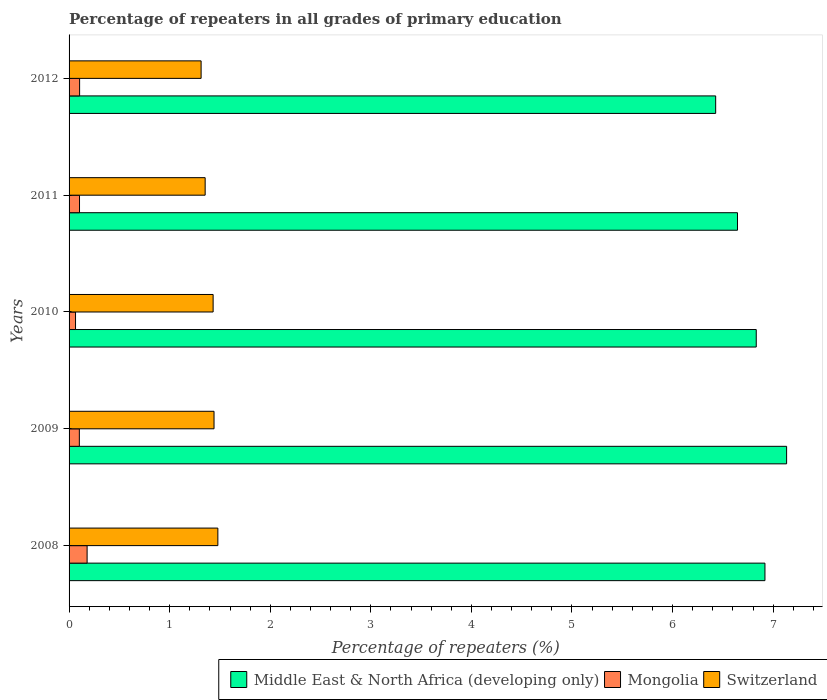How many different coloured bars are there?
Give a very brief answer. 3. How many bars are there on the 5th tick from the top?
Provide a short and direct response. 3. How many bars are there on the 2nd tick from the bottom?
Offer a terse response. 3. What is the percentage of repeaters in Middle East & North Africa (developing only) in 2008?
Offer a very short reply. 6.92. Across all years, what is the maximum percentage of repeaters in Mongolia?
Your answer should be very brief. 0.18. Across all years, what is the minimum percentage of repeaters in Switzerland?
Make the answer very short. 1.31. What is the total percentage of repeaters in Middle East & North Africa (developing only) in the graph?
Your response must be concise. 33.96. What is the difference between the percentage of repeaters in Mongolia in 2011 and that in 2012?
Offer a terse response. -0. What is the difference between the percentage of repeaters in Mongolia in 2008 and the percentage of repeaters in Middle East & North Africa (developing only) in 2012?
Provide a short and direct response. -6.25. What is the average percentage of repeaters in Middle East & North Africa (developing only) per year?
Provide a short and direct response. 6.79. In the year 2012, what is the difference between the percentage of repeaters in Middle East & North Africa (developing only) and percentage of repeaters in Switzerland?
Ensure brevity in your answer.  5.12. In how many years, is the percentage of repeaters in Switzerland greater than 3.2 %?
Make the answer very short. 0. What is the ratio of the percentage of repeaters in Switzerland in 2009 to that in 2010?
Your answer should be very brief. 1.01. What is the difference between the highest and the second highest percentage of repeaters in Middle East & North Africa (developing only)?
Your response must be concise. 0.22. What is the difference between the highest and the lowest percentage of repeaters in Middle East & North Africa (developing only)?
Ensure brevity in your answer.  0.71. What does the 3rd bar from the top in 2009 represents?
Your answer should be very brief. Middle East & North Africa (developing only). What does the 3rd bar from the bottom in 2009 represents?
Your answer should be very brief. Switzerland. What is the difference between two consecutive major ticks on the X-axis?
Make the answer very short. 1. Are the values on the major ticks of X-axis written in scientific E-notation?
Your answer should be compact. No. How are the legend labels stacked?
Provide a short and direct response. Horizontal. What is the title of the graph?
Keep it short and to the point. Percentage of repeaters in all grades of primary education. What is the label or title of the X-axis?
Your response must be concise. Percentage of repeaters (%). What is the Percentage of repeaters (%) of Middle East & North Africa (developing only) in 2008?
Provide a succinct answer. 6.92. What is the Percentage of repeaters (%) of Mongolia in 2008?
Provide a short and direct response. 0.18. What is the Percentage of repeaters (%) of Switzerland in 2008?
Keep it short and to the point. 1.48. What is the Percentage of repeaters (%) of Middle East & North Africa (developing only) in 2009?
Offer a terse response. 7.13. What is the Percentage of repeaters (%) in Mongolia in 2009?
Your response must be concise. 0.1. What is the Percentage of repeaters (%) of Switzerland in 2009?
Provide a succinct answer. 1.44. What is the Percentage of repeaters (%) in Middle East & North Africa (developing only) in 2010?
Offer a very short reply. 6.83. What is the Percentage of repeaters (%) in Mongolia in 2010?
Provide a short and direct response. 0.06. What is the Percentage of repeaters (%) in Switzerland in 2010?
Your response must be concise. 1.43. What is the Percentage of repeaters (%) in Middle East & North Africa (developing only) in 2011?
Provide a short and direct response. 6.65. What is the Percentage of repeaters (%) of Mongolia in 2011?
Your answer should be very brief. 0.1. What is the Percentage of repeaters (%) in Switzerland in 2011?
Offer a terse response. 1.35. What is the Percentage of repeaters (%) in Middle East & North Africa (developing only) in 2012?
Your answer should be compact. 6.43. What is the Percentage of repeaters (%) of Mongolia in 2012?
Provide a short and direct response. 0.1. What is the Percentage of repeaters (%) in Switzerland in 2012?
Offer a very short reply. 1.31. Across all years, what is the maximum Percentage of repeaters (%) of Middle East & North Africa (developing only)?
Your response must be concise. 7.13. Across all years, what is the maximum Percentage of repeaters (%) in Mongolia?
Provide a succinct answer. 0.18. Across all years, what is the maximum Percentage of repeaters (%) in Switzerland?
Your response must be concise. 1.48. Across all years, what is the minimum Percentage of repeaters (%) in Middle East & North Africa (developing only)?
Your answer should be very brief. 6.43. Across all years, what is the minimum Percentage of repeaters (%) in Mongolia?
Provide a succinct answer. 0.06. Across all years, what is the minimum Percentage of repeaters (%) in Switzerland?
Offer a very short reply. 1.31. What is the total Percentage of repeaters (%) in Middle East & North Africa (developing only) in the graph?
Make the answer very short. 33.96. What is the total Percentage of repeaters (%) of Mongolia in the graph?
Keep it short and to the point. 0.55. What is the total Percentage of repeaters (%) of Switzerland in the graph?
Your answer should be compact. 7.02. What is the difference between the Percentage of repeaters (%) of Middle East & North Africa (developing only) in 2008 and that in 2009?
Offer a very short reply. -0.22. What is the difference between the Percentage of repeaters (%) in Mongolia in 2008 and that in 2009?
Offer a terse response. 0.08. What is the difference between the Percentage of repeaters (%) of Switzerland in 2008 and that in 2009?
Ensure brevity in your answer.  0.04. What is the difference between the Percentage of repeaters (%) in Middle East & North Africa (developing only) in 2008 and that in 2010?
Your answer should be very brief. 0.09. What is the difference between the Percentage of repeaters (%) in Mongolia in 2008 and that in 2010?
Ensure brevity in your answer.  0.12. What is the difference between the Percentage of repeaters (%) of Switzerland in 2008 and that in 2010?
Offer a terse response. 0.05. What is the difference between the Percentage of repeaters (%) in Middle East & North Africa (developing only) in 2008 and that in 2011?
Make the answer very short. 0.27. What is the difference between the Percentage of repeaters (%) in Mongolia in 2008 and that in 2011?
Make the answer very short. 0.08. What is the difference between the Percentage of repeaters (%) in Switzerland in 2008 and that in 2011?
Give a very brief answer. 0.13. What is the difference between the Percentage of repeaters (%) of Middle East & North Africa (developing only) in 2008 and that in 2012?
Give a very brief answer. 0.49. What is the difference between the Percentage of repeaters (%) of Mongolia in 2008 and that in 2012?
Keep it short and to the point. 0.07. What is the difference between the Percentage of repeaters (%) in Switzerland in 2008 and that in 2012?
Offer a terse response. 0.17. What is the difference between the Percentage of repeaters (%) in Middle East & North Africa (developing only) in 2009 and that in 2010?
Ensure brevity in your answer.  0.3. What is the difference between the Percentage of repeaters (%) in Mongolia in 2009 and that in 2010?
Your answer should be compact. 0.04. What is the difference between the Percentage of repeaters (%) in Switzerland in 2009 and that in 2010?
Your answer should be compact. 0.01. What is the difference between the Percentage of repeaters (%) of Middle East & North Africa (developing only) in 2009 and that in 2011?
Keep it short and to the point. 0.49. What is the difference between the Percentage of repeaters (%) in Mongolia in 2009 and that in 2011?
Provide a short and direct response. -0. What is the difference between the Percentage of repeaters (%) in Switzerland in 2009 and that in 2011?
Offer a very short reply. 0.09. What is the difference between the Percentage of repeaters (%) in Middle East & North Africa (developing only) in 2009 and that in 2012?
Ensure brevity in your answer.  0.71. What is the difference between the Percentage of repeaters (%) of Mongolia in 2009 and that in 2012?
Keep it short and to the point. -0. What is the difference between the Percentage of repeaters (%) of Switzerland in 2009 and that in 2012?
Ensure brevity in your answer.  0.13. What is the difference between the Percentage of repeaters (%) of Middle East & North Africa (developing only) in 2010 and that in 2011?
Offer a terse response. 0.19. What is the difference between the Percentage of repeaters (%) of Mongolia in 2010 and that in 2011?
Your answer should be compact. -0.04. What is the difference between the Percentage of repeaters (%) of Switzerland in 2010 and that in 2011?
Make the answer very short. 0.08. What is the difference between the Percentage of repeaters (%) in Middle East & North Africa (developing only) in 2010 and that in 2012?
Provide a short and direct response. 0.4. What is the difference between the Percentage of repeaters (%) in Mongolia in 2010 and that in 2012?
Your response must be concise. -0.04. What is the difference between the Percentage of repeaters (%) of Switzerland in 2010 and that in 2012?
Offer a terse response. 0.12. What is the difference between the Percentage of repeaters (%) of Middle East & North Africa (developing only) in 2011 and that in 2012?
Give a very brief answer. 0.22. What is the difference between the Percentage of repeaters (%) in Mongolia in 2011 and that in 2012?
Your response must be concise. -0. What is the difference between the Percentage of repeaters (%) in Switzerland in 2011 and that in 2012?
Provide a short and direct response. 0.04. What is the difference between the Percentage of repeaters (%) of Middle East & North Africa (developing only) in 2008 and the Percentage of repeaters (%) of Mongolia in 2009?
Ensure brevity in your answer.  6.82. What is the difference between the Percentage of repeaters (%) of Middle East & North Africa (developing only) in 2008 and the Percentage of repeaters (%) of Switzerland in 2009?
Ensure brevity in your answer.  5.48. What is the difference between the Percentage of repeaters (%) of Mongolia in 2008 and the Percentage of repeaters (%) of Switzerland in 2009?
Your answer should be compact. -1.26. What is the difference between the Percentage of repeaters (%) of Middle East & North Africa (developing only) in 2008 and the Percentage of repeaters (%) of Mongolia in 2010?
Your answer should be very brief. 6.85. What is the difference between the Percentage of repeaters (%) in Middle East & North Africa (developing only) in 2008 and the Percentage of repeaters (%) in Switzerland in 2010?
Keep it short and to the point. 5.49. What is the difference between the Percentage of repeaters (%) in Mongolia in 2008 and the Percentage of repeaters (%) in Switzerland in 2010?
Provide a succinct answer. -1.25. What is the difference between the Percentage of repeaters (%) of Middle East & North Africa (developing only) in 2008 and the Percentage of repeaters (%) of Mongolia in 2011?
Offer a terse response. 6.82. What is the difference between the Percentage of repeaters (%) of Middle East & North Africa (developing only) in 2008 and the Percentage of repeaters (%) of Switzerland in 2011?
Keep it short and to the point. 5.57. What is the difference between the Percentage of repeaters (%) of Mongolia in 2008 and the Percentage of repeaters (%) of Switzerland in 2011?
Offer a very short reply. -1.17. What is the difference between the Percentage of repeaters (%) in Middle East & North Africa (developing only) in 2008 and the Percentage of repeaters (%) in Mongolia in 2012?
Offer a terse response. 6.81. What is the difference between the Percentage of repeaters (%) in Middle East & North Africa (developing only) in 2008 and the Percentage of repeaters (%) in Switzerland in 2012?
Provide a succinct answer. 5.61. What is the difference between the Percentage of repeaters (%) in Mongolia in 2008 and the Percentage of repeaters (%) in Switzerland in 2012?
Provide a short and direct response. -1.13. What is the difference between the Percentage of repeaters (%) of Middle East & North Africa (developing only) in 2009 and the Percentage of repeaters (%) of Mongolia in 2010?
Keep it short and to the point. 7.07. What is the difference between the Percentage of repeaters (%) of Middle East & North Africa (developing only) in 2009 and the Percentage of repeaters (%) of Switzerland in 2010?
Offer a very short reply. 5.7. What is the difference between the Percentage of repeaters (%) in Mongolia in 2009 and the Percentage of repeaters (%) in Switzerland in 2010?
Keep it short and to the point. -1.33. What is the difference between the Percentage of repeaters (%) in Middle East & North Africa (developing only) in 2009 and the Percentage of repeaters (%) in Mongolia in 2011?
Make the answer very short. 7.03. What is the difference between the Percentage of repeaters (%) in Middle East & North Africa (developing only) in 2009 and the Percentage of repeaters (%) in Switzerland in 2011?
Offer a very short reply. 5.78. What is the difference between the Percentage of repeaters (%) of Mongolia in 2009 and the Percentage of repeaters (%) of Switzerland in 2011?
Your response must be concise. -1.25. What is the difference between the Percentage of repeaters (%) of Middle East & North Africa (developing only) in 2009 and the Percentage of repeaters (%) of Mongolia in 2012?
Give a very brief answer. 7.03. What is the difference between the Percentage of repeaters (%) in Middle East & North Africa (developing only) in 2009 and the Percentage of repeaters (%) in Switzerland in 2012?
Offer a very short reply. 5.82. What is the difference between the Percentage of repeaters (%) in Mongolia in 2009 and the Percentage of repeaters (%) in Switzerland in 2012?
Your response must be concise. -1.21. What is the difference between the Percentage of repeaters (%) in Middle East & North Africa (developing only) in 2010 and the Percentage of repeaters (%) in Mongolia in 2011?
Offer a very short reply. 6.73. What is the difference between the Percentage of repeaters (%) in Middle East & North Africa (developing only) in 2010 and the Percentage of repeaters (%) in Switzerland in 2011?
Provide a succinct answer. 5.48. What is the difference between the Percentage of repeaters (%) in Mongolia in 2010 and the Percentage of repeaters (%) in Switzerland in 2011?
Offer a very short reply. -1.29. What is the difference between the Percentage of repeaters (%) in Middle East & North Africa (developing only) in 2010 and the Percentage of repeaters (%) in Mongolia in 2012?
Offer a terse response. 6.73. What is the difference between the Percentage of repeaters (%) of Middle East & North Africa (developing only) in 2010 and the Percentage of repeaters (%) of Switzerland in 2012?
Offer a very short reply. 5.52. What is the difference between the Percentage of repeaters (%) in Mongolia in 2010 and the Percentage of repeaters (%) in Switzerland in 2012?
Provide a succinct answer. -1.25. What is the difference between the Percentage of repeaters (%) of Middle East & North Africa (developing only) in 2011 and the Percentage of repeaters (%) of Mongolia in 2012?
Provide a short and direct response. 6.54. What is the difference between the Percentage of repeaters (%) in Middle East & North Africa (developing only) in 2011 and the Percentage of repeaters (%) in Switzerland in 2012?
Make the answer very short. 5.33. What is the difference between the Percentage of repeaters (%) of Mongolia in 2011 and the Percentage of repeaters (%) of Switzerland in 2012?
Your answer should be compact. -1.21. What is the average Percentage of repeaters (%) in Middle East & North Africa (developing only) per year?
Offer a very short reply. 6.79. What is the average Percentage of repeaters (%) in Mongolia per year?
Your answer should be compact. 0.11. What is the average Percentage of repeaters (%) in Switzerland per year?
Your answer should be compact. 1.4. In the year 2008, what is the difference between the Percentage of repeaters (%) in Middle East & North Africa (developing only) and Percentage of repeaters (%) in Mongolia?
Your answer should be compact. 6.74. In the year 2008, what is the difference between the Percentage of repeaters (%) of Middle East & North Africa (developing only) and Percentage of repeaters (%) of Switzerland?
Your response must be concise. 5.44. In the year 2008, what is the difference between the Percentage of repeaters (%) in Mongolia and Percentage of repeaters (%) in Switzerland?
Offer a very short reply. -1.3. In the year 2009, what is the difference between the Percentage of repeaters (%) in Middle East & North Africa (developing only) and Percentage of repeaters (%) in Mongolia?
Provide a succinct answer. 7.03. In the year 2009, what is the difference between the Percentage of repeaters (%) in Middle East & North Africa (developing only) and Percentage of repeaters (%) in Switzerland?
Give a very brief answer. 5.69. In the year 2009, what is the difference between the Percentage of repeaters (%) of Mongolia and Percentage of repeaters (%) of Switzerland?
Your answer should be very brief. -1.34. In the year 2010, what is the difference between the Percentage of repeaters (%) of Middle East & North Africa (developing only) and Percentage of repeaters (%) of Mongolia?
Your answer should be very brief. 6.77. In the year 2010, what is the difference between the Percentage of repeaters (%) in Middle East & North Africa (developing only) and Percentage of repeaters (%) in Switzerland?
Provide a succinct answer. 5.4. In the year 2010, what is the difference between the Percentage of repeaters (%) in Mongolia and Percentage of repeaters (%) in Switzerland?
Provide a succinct answer. -1.37. In the year 2011, what is the difference between the Percentage of repeaters (%) of Middle East & North Africa (developing only) and Percentage of repeaters (%) of Mongolia?
Provide a short and direct response. 6.54. In the year 2011, what is the difference between the Percentage of repeaters (%) in Middle East & North Africa (developing only) and Percentage of repeaters (%) in Switzerland?
Give a very brief answer. 5.29. In the year 2011, what is the difference between the Percentage of repeaters (%) of Mongolia and Percentage of repeaters (%) of Switzerland?
Offer a terse response. -1.25. In the year 2012, what is the difference between the Percentage of repeaters (%) in Middle East & North Africa (developing only) and Percentage of repeaters (%) in Mongolia?
Offer a very short reply. 6.32. In the year 2012, what is the difference between the Percentage of repeaters (%) in Middle East & North Africa (developing only) and Percentage of repeaters (%) in Switzerland?
Your answer should be compact. 5.12. In the year 2012, what is the difference between the Percentage of repeaters (%) of Mongolia and Percentage of repeaters (%) of Switzerland?
Give a very brief answer. -1.21. What is the ratio of the Percentage of repeaters (%) in Middle East & North Africa (developing only) in 2008 to that in 2009?
Keep it short and to the point. 0.97. What is the ratio of the Percentage of repeaters (%) of Mongolia in 2008 to that in 2009?
Provide a succinct answer. 1.76. What is the ratio of the Percentage of repeaters (%) of Switzerland in 2008 to that in 2009?
Your answer should be compact. 1.03. What is the ratio of the Percentage of repeaters (%) in Middle East & North Africa (developing only) in 2008 to that in 2010?
Your response must be concise. 1.01. What is the ratio of the Percentage of repeaters (%) in Mongolia in 2008 to that in 2010?
Your response must be concise. 2.79. What is the ratio of the Percentage of repeaters (%) in Switzerland in 2008 to that in 2010?
Offer a terse response. 1.03. What is the ratio of the Percentage of repeaters (%) in Middle East & North Africa (developing only) in 2008 to that in 2011?
Provide a succinct answer. 1.04. What is the ratio of the Percentage of repeaters (%) of Mongolia in 2008 to that in 2011?
Offer a terse response. 1.73. What is the ratio of the Percentage of repeaters (%) of Switzerland in 2008 to that in 2011?
Your response must be concise. 1.09. What is the ratio of the Percentage of repeaters (%) in Middle East & North Africa (developing only) in 2008 to that in 2012?
Offer a terse response. 1.08. What is the ratio of the Percentage of repeaters (%) of Mongolia in 2008 to that in 2012?
Keep it short and to the point. 1.71. What is the ratio of the Percentage of repeaters (%) of Switzerland in 2008 to that in 2012?
Offer a terse response. 1.13. What is the ratio of the Percentage of repeaters (%) in Middle East & North Africa (developing only) in 2009 to that in 2010?
Make the answer very short. 1.04. What is the ratio of the Percentage of repeaters (%) in Mongolia in 2009 to that in 2010?
Provide a succinct answer. 1.59. What is the ratio of the Percentage of repeaters (%) in Middle East & North Africa (developing only) in 2009 to that in 2011?
Your response must be concise. 1.07. What is the ratio of the Percentage of repeaters (%) in Mongolia in 2009 to that in 2011?
Your answer should be compact. 0.98. What is the ratio of the Percentage of repeaters (%) of Switzerland in 2009 to that in 2011?
Keep it short and to the point. 1.07. What is the ratio of the Percentage of repeaters (%) of Middle East & North Africa (developing only) in 2009 to that in 2012?
Provide a succinct answer. 1.11. What is the ratio of the Percentage of repeaters (%) in Mongolia in 2009 to that in 2012?
Offer a terse response. 0.97. What is the ratio of the Percentage of repeaters (%) of Switzerland in 2009 to that in 2012?
Give a very brief answer. 1.1. What is the ratio of the Percentage of repeaters (%) in Middle East & North Africa (developing only) in 2010 to that in 2011?
Ensure brevity in your answer.  1.03. What is the ratio of the Percentage of repeaters (%) of Mongolia in 2010 to that in 2011?
Your response must be concise. 0.62. What is the ratio of the Percentage of repeaters (%) of Switzerland in 2010 to that in 2011?
Provide a short and direct response. 1.06. What is the ratio of the Percentage of repeaters (%) of Middle East & North Africa (developing only) in 2010 to that in 2012?
Provide a succinct answer. 1.06. What is the ratio of the Percentage of repeaters (%) of Mongolia in 2010 to that in 2012?
Offer a terse response. 0.61. What is the ratio of the Percentage of repeaters (%) of Switzerland in 2010 to that in 2012?
Make the answer very short. 1.09. What is the ratio of the Percentage of repeaters (%) of Middle East & North Africa (developing only) in 2011 to that in 2012?
Offer a very short reply. 1.03. What is the ratio of the Percentage of repeaters (%) in Switzerland in 2011 to that in 2012?
Your answer should be compact. 1.03. What is the difference between the highest and the second highest Percentage of repeaters (%) in Middle East & North Africa (developing only)?
Your response must be concise. 0.22. What is the difference between the highest and the second highest Percentage of repeaters (%) of Mongolia?
Give a very brief answer. 0.07. What is the difference between the highest and the second highest Percentage of repeaters (%) of Switzerland?
Offer a terse response. 0.04. What is the difference between the highest and the lowest Percentage of repeaters (%) in Middle East & North Africa (developing only)?
Make the answer very short. 0.71. What is the difference between the highest and the lowest Percentage of repeaters (%) in Mongolia?
Provide a short and direct response. 0.12. What is the difference between the highest and the lowest Percentage of repeaters (%) in Switzerland?
Keep it short and to the point. 0.17. 